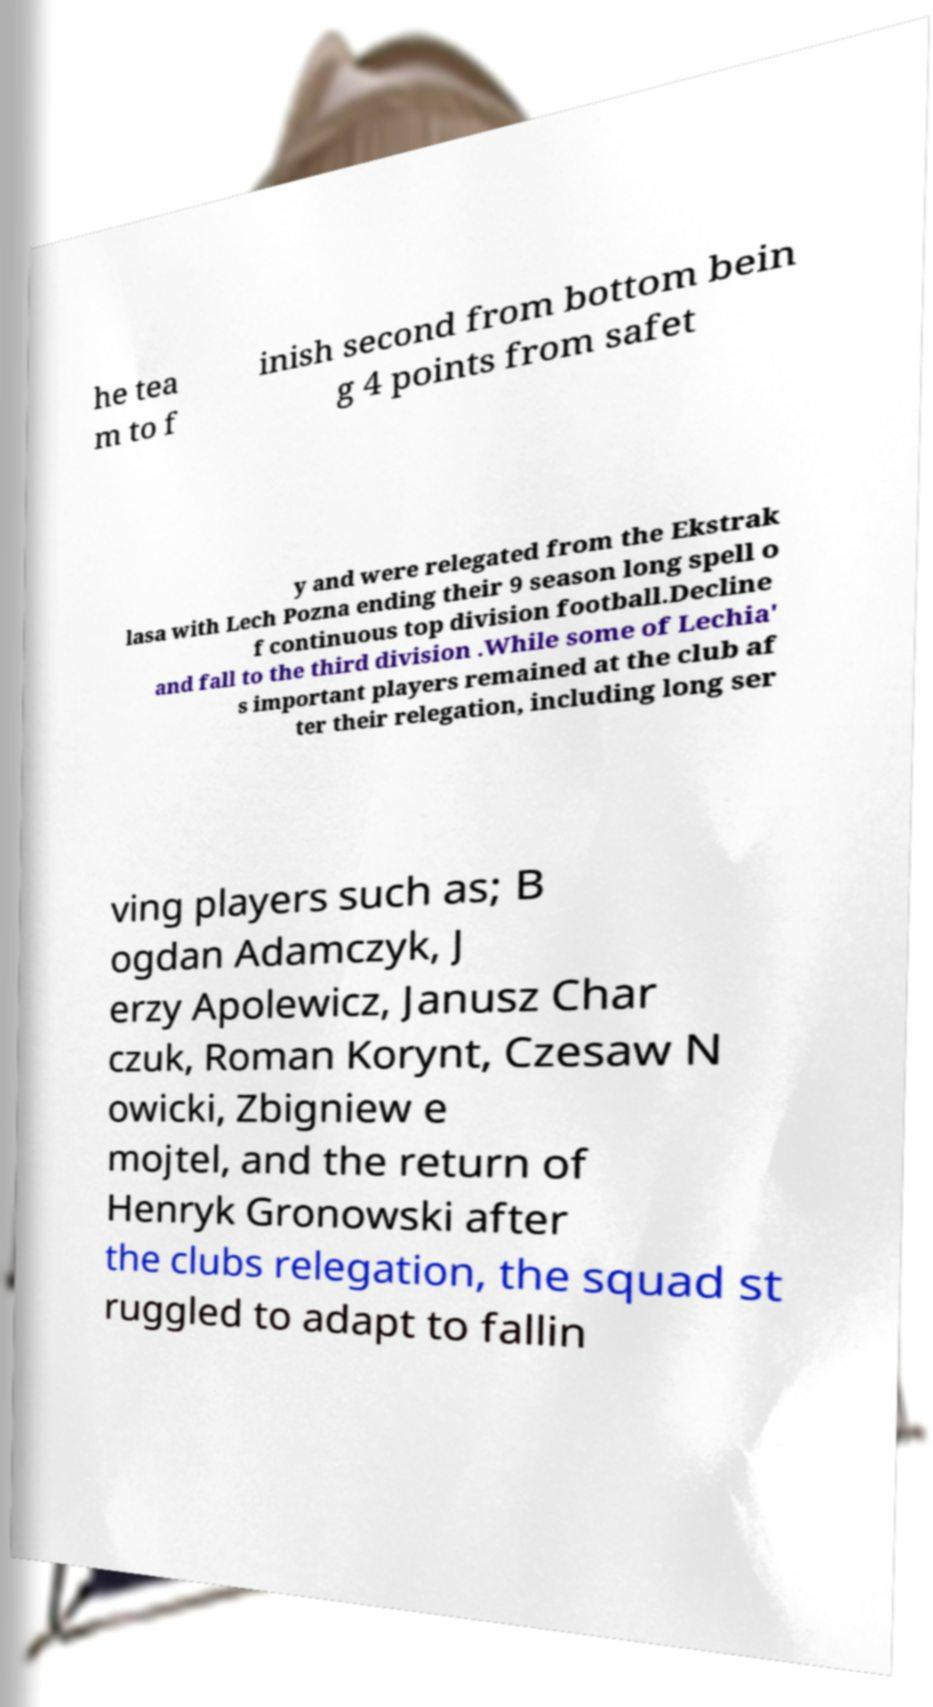I need the written content from this picture converted into text. Can you do that? he tea m to f inish second from bottom bein g 4 points from safet y and were relegated from the Ekstrak lasa with Lech Pozna ending their 9 season long spell o f continuous top division football.Decline and fall to the third division .While some of Lechia' s important players remained at the club af ter their relegation, including long ser ving players such as; B ogdan Adamczyk, J erzy Apolewicz, Janusz Char czuk, Roman Korynt, Czesaw N owicki, Zbigniew e mojtel, and the return of Henryk Gronowski after the clubs relegation, the squad st ruggled to adapt to fallin 